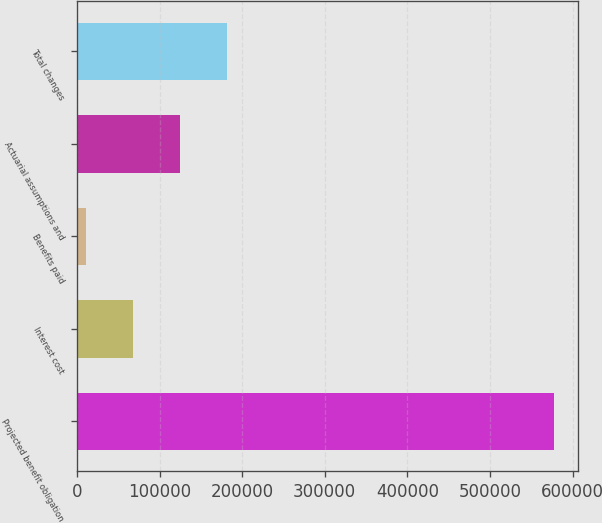Convert chart to OTSL. <chart><loc_0><loc_0><loc_500><loc_500><bar_chart><fcel>Projected benefit obligation<fcel>Interest cost<fcel>Benefits paid<fcel>Actuarial assumptions and<fcel>Total changes<nl><fcel>577770<fcel>68007.3<fcel>11367<fcel>124648<fcel>181288<nl></chart> 